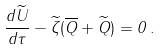Convert formula to latex. <formula><loc_0><loc_0><loc_500><loc_500>\frac { d \widetilde { U } } { d \tau } - \widetilde { \zeta } ( \overline { Q } + \widetilde { Q } ) = 0 \, .</formula> 